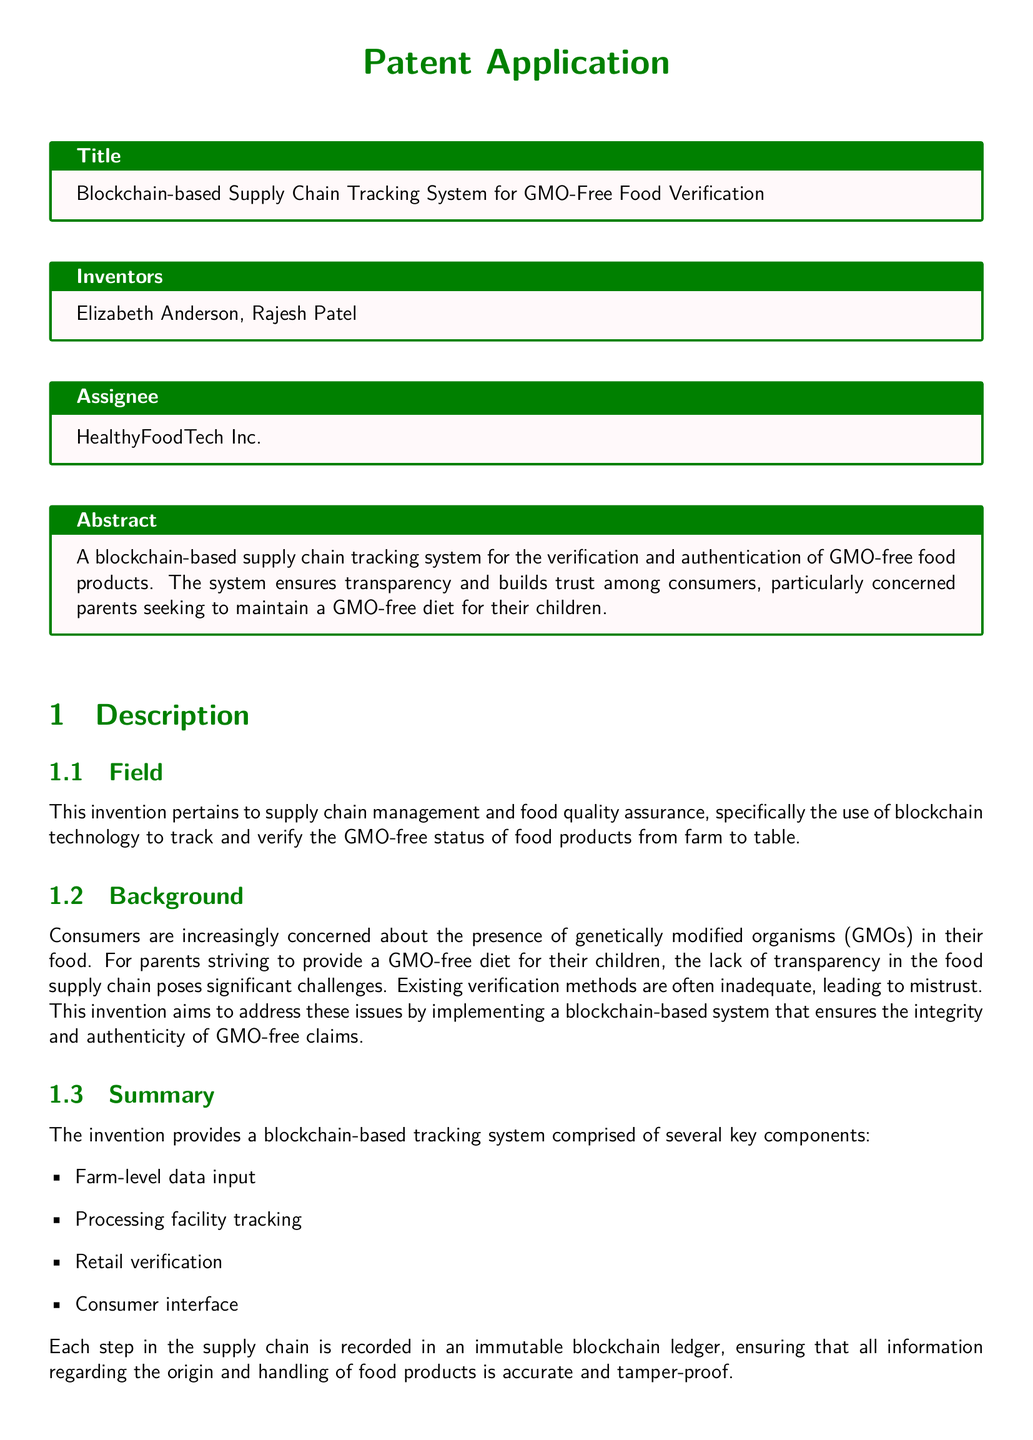what is the title of the patent application? The title of the patent application is specified in the 'Title' section of the document.
Answer: Blockchain-based Supply Chain Tracking System for GMO-Free Food Verification who are the inventors of the system? The inventors are listed in the 'Inventors' section of the document.
Answer: Elizabeth Anderson, Rajesh Patel what company is the assignee for the patent? The assignee is the organization that holds the rights to the patent, listed in the 'Assignee' section.
Answer: HealthyFoodTech Inc what are the key components of the tracking system? The key components are outlined in the 'Summary' section, detailing the steps involved in the tracking system.
Answer: Farm-level data input, Processing facility tracking, Retail verification, Consumer interface how does the system ensure data integrity? The method discusses the use of an immutable blockchain ledger to guarantee the security of data.
Answer: Immutable blockchain ledger what problem does the invention aim to address? The issue to be solved relates to the lack of transparency in verifying GMO-free food products, mentioned in the 'Background' section.
Answer: Lack of transparency what step is included in the method for verifying GMO-free status? The method outlines various steps, one being receiving farming data from a mobile app used by farmers.
Answer: Receiving farming data how many claims are made in the document? The number of claims in a patent application is typically listed in the 'Claims' section.
Answer: Three claims what is the purpose of the consumer-facing mobile application? The function of the application is described in relation to ensuring transparency for consumers.
Answer: Transparency 